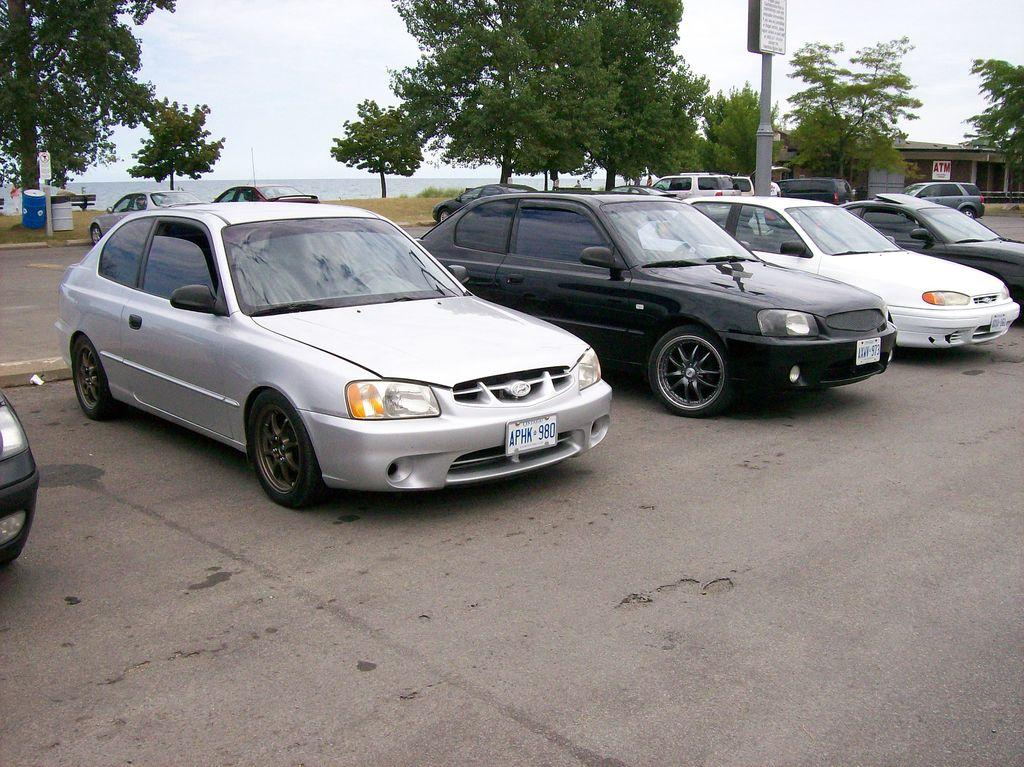What can be seen on the road in the image? There are vehicles on the road in the image. What type of natural elements are visible in the image? There are trees visible in the image. What type of material is present in the image? There is shred visible in the image. Can you see a robin playing an instrument in the image? There is no robin or instrument present in the image. What color is the neck of the tree in the image? Trees do not have necks, so this question cannot be answered. 